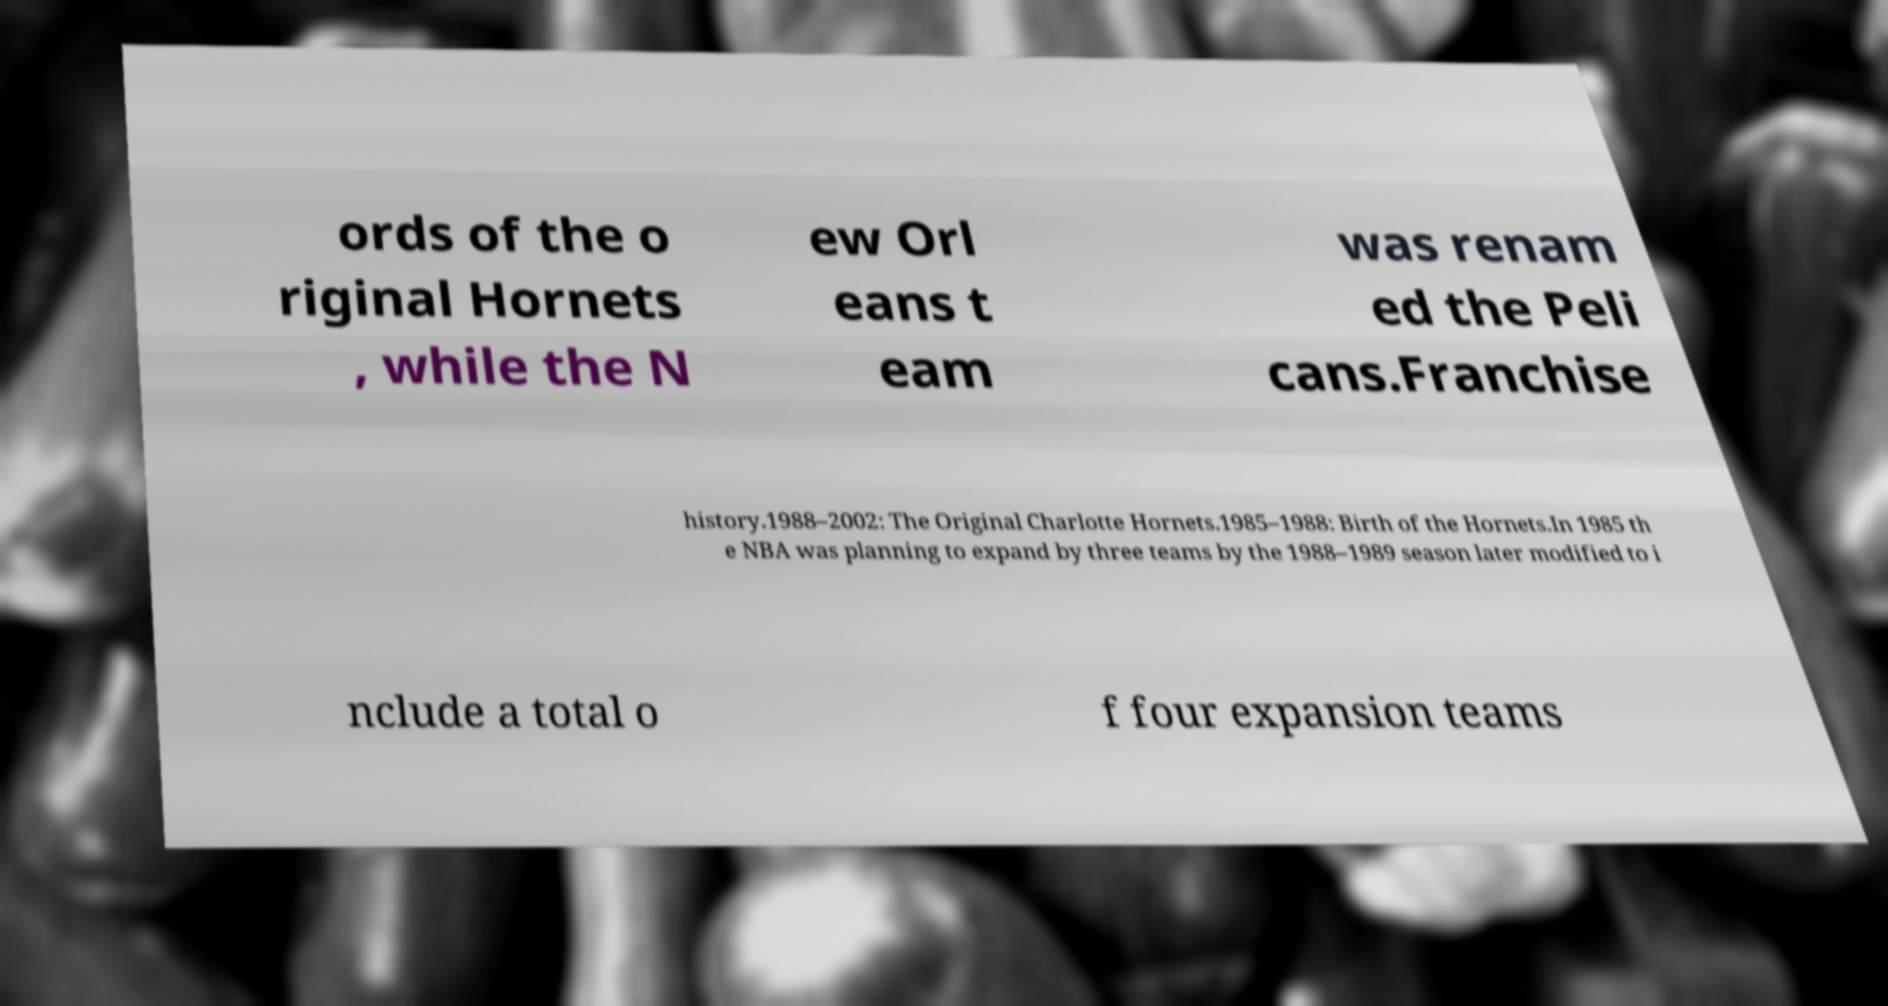I need the written content from this picture converted into text. Can you do that? ords of the o riginal Hornets , while the N ew Orl eans t eam was renam ed the Peli cans.Franchise history.1988–2002: The Original Charlotte Hornets.1985–1988: Birth of the Hornets.In 1985 th e NBA was planning to expand by three teams by the 1988–1989 season later modified to i nclude a total o f four expansion teams 